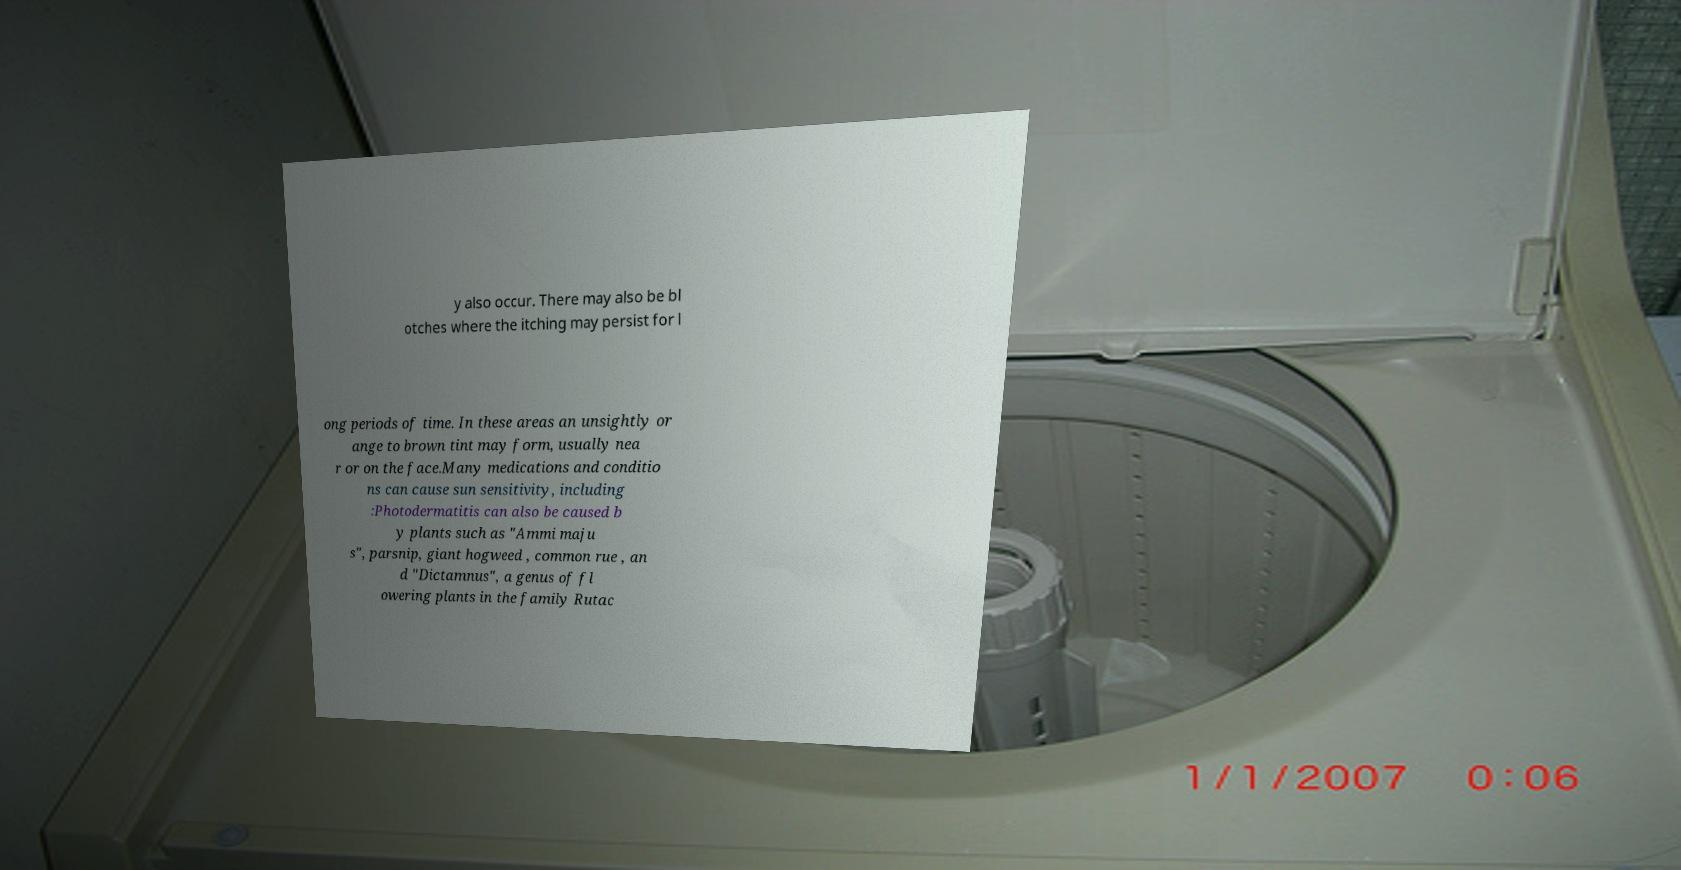I need the written content from this picture converted into text. Can you do that? y also occur. There may also be bl otches where the itching may persist for l ong periods of time. In these areas an unsightly or ange to brown tint may form, usually nea r or on the face.Many medications and conditio ns can cause sun sensitivity, including :Photodermatitis can also be caused b y plants such as "Ammi maju s", parsnip, giant hogweed , common rue , an d "Dictamnus", a genus of fl owering plants in the family Rutac 